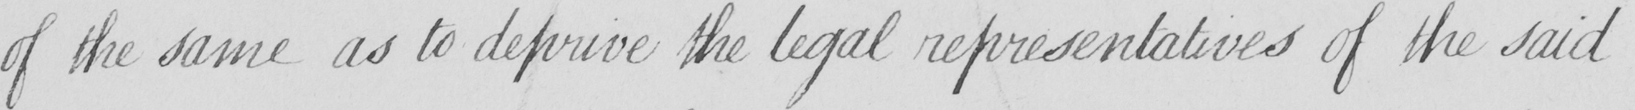Can you tell me what this handwritten text says? of the same as to deprive the legal representatives of the said 